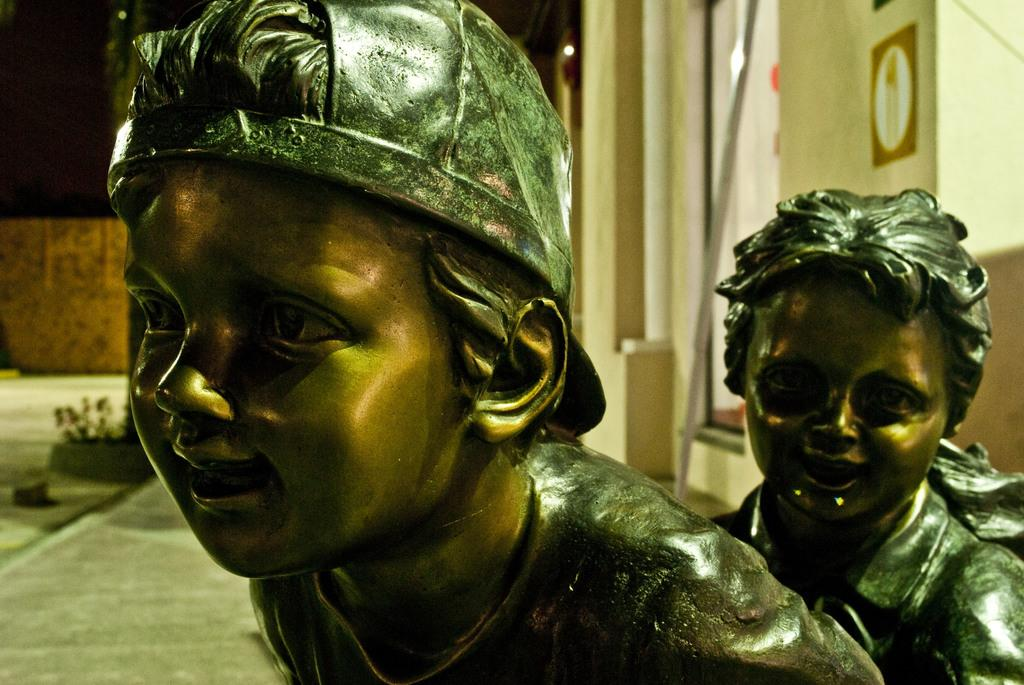What type of objects can be seen in the image? There are statues in the image. What can be seen in the distance behind the statues? There is a building in the background of the image. Is there any source of illumination visible in the image? Yes, there is a light visible in the image. Can you tell me how many swings are present in the image? There are no swings present in the image; it features statues and a building in the background. What type of door can be seen on the building in the image? There is no door visible on the building in the image; only the building itself is visible in the background. 